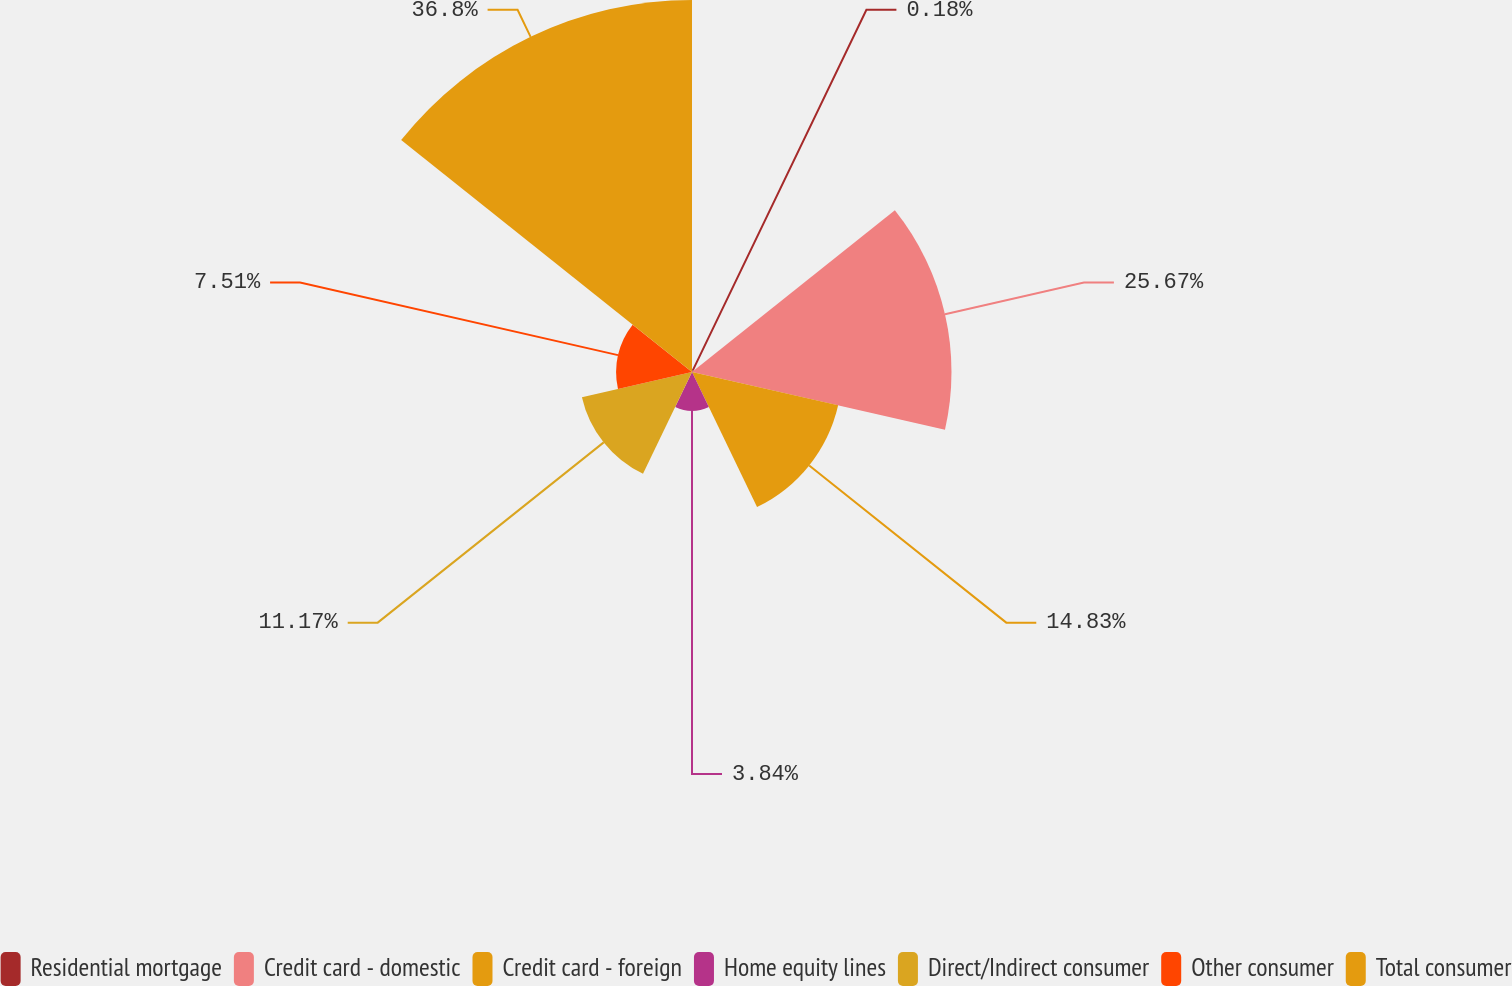Convert chart. <chart><loc_0><loc_0><loc_500><loc_500><pie_chart><fcel>Residential mortgage<fcel>Credit card - domestic<fcel>Credit card - foreign<fcel>Home equity lines<fcel>Direct/Indirect consumer<fcel>Other consumer<fcel>Total consumer<nl><fcel>0.18%<fcel>25.67%<fcel>14.83%<fcel>3.84%<fcel>11.17%<fcel>7.51%<fcel>36.8%<nl></chart> 